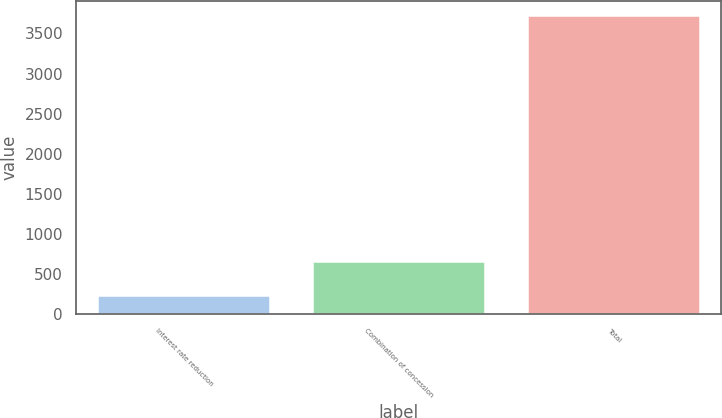Convert chart. <chart><loc_0><loc_0><loc_500><loc_500><bar_chart><fcel>Interest rate reduction<fcel>Combination of concession<fcel>Total<nl><fcel>231<fcel>651<fcel>3723<nl></chart> 